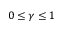Convert formula to latex. <formula><loc_0><loc_0><loc_500><loc_500>0 \leq \gamma \leq 1</formula> 